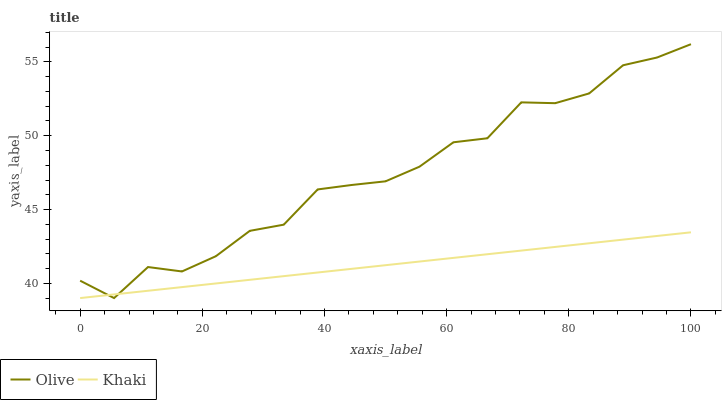Does Khaki have the minimum area under the curve?
Answer yes or no. Yes. Does Olive have the maximum area under the curve?
Answer yes or no. Yes. Does Khaki have the maximum area under the curve?
Answer yes or no. No. Is Khaki the smoothest?
Answer yes or no. Yes. Is Olive the roughest?
Answer yes or no. Yes. Is Khaki the roughest?
Answer yes or no. No. Does Olive have the lowest value?
Answer yes or no. Yes. Does Olive have the highest value?
Answer yes or no. Yes. Does Khaki have the highest value?
Answer yes or no. No. Does Khaki intersect Olive?
Answer yes or no. Yes. Is Khaki less than Olive?
Answer yes or no. No. Is Khaki greater than Olive?
Answer yes or no. No. 